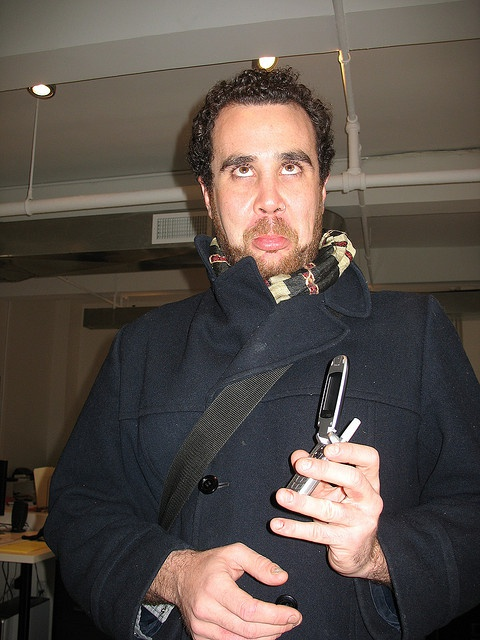Describe the objects in this image and their specific colors. I can see people in gray, black, and salmon tones and cell phone in gray, white, black, and darkgray tones in this image. 